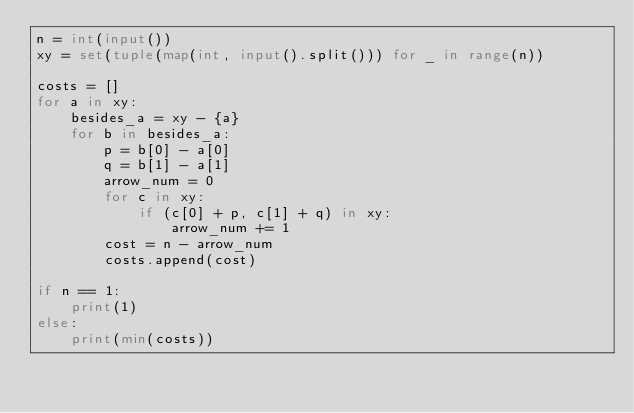Convert code to text. <code><loc_0><loc_0><loc_500><loc_500><_Python_>n = int(input())
xy = set(tuple(map(int, input().split())) for _ in range(n))

costs = []
for a in xy:
    besides_a = xy - {a}
    for b in besides_a:
        p = b[0] - a[0]
        q = b[1] - a[1]
        arrow_num = 0
        for c in xy:
            if (c[0] + p, c[1] + q) in xy:
                arrow_num += 1
        cost = n - arrow_num
        costs.append(cost)

if n == 1:
    print(1)
else:
    print(min(costs))
</code> 